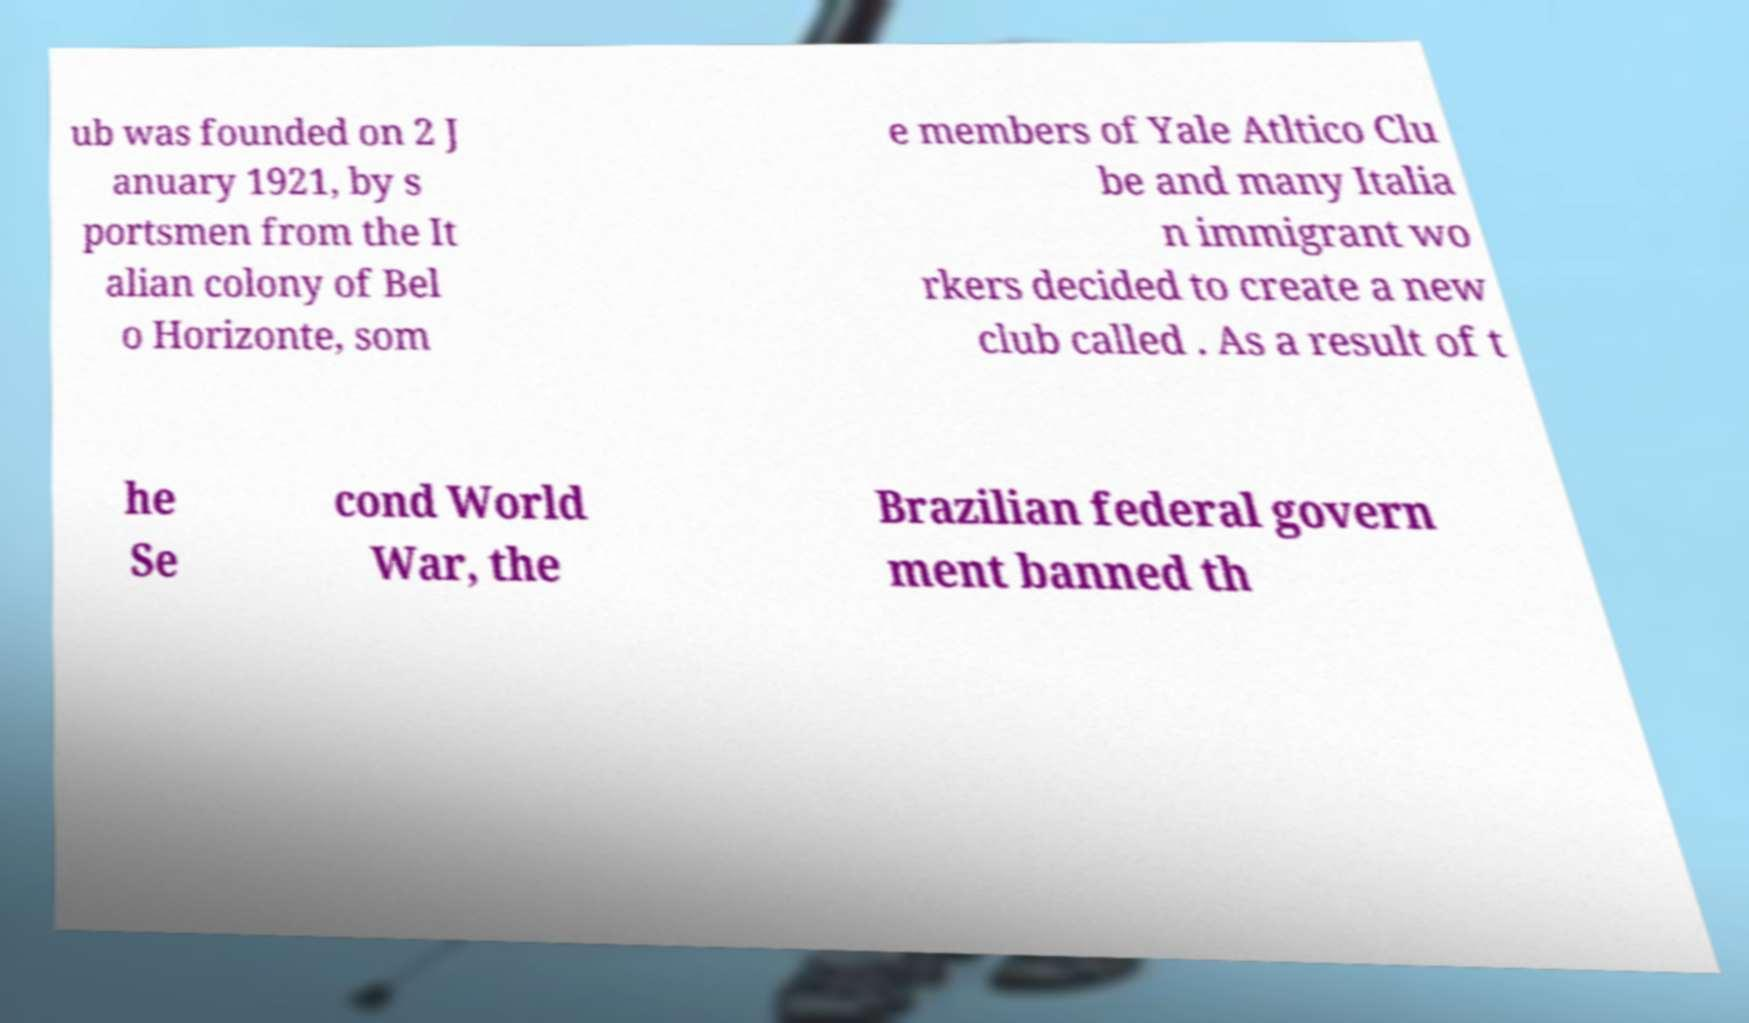Can you accurately transcribe the text from the provided image for me? ub was founded on 2 J anuary 1921, by s portsmen from the It alian colony of Bel o Horizonte, som e members of Yale Atltico Clu be and many Italia n immigrant wo rkers decided to create a new club called . As a result of t he Se cond World War, the Brazilian federal govern ment banned th 